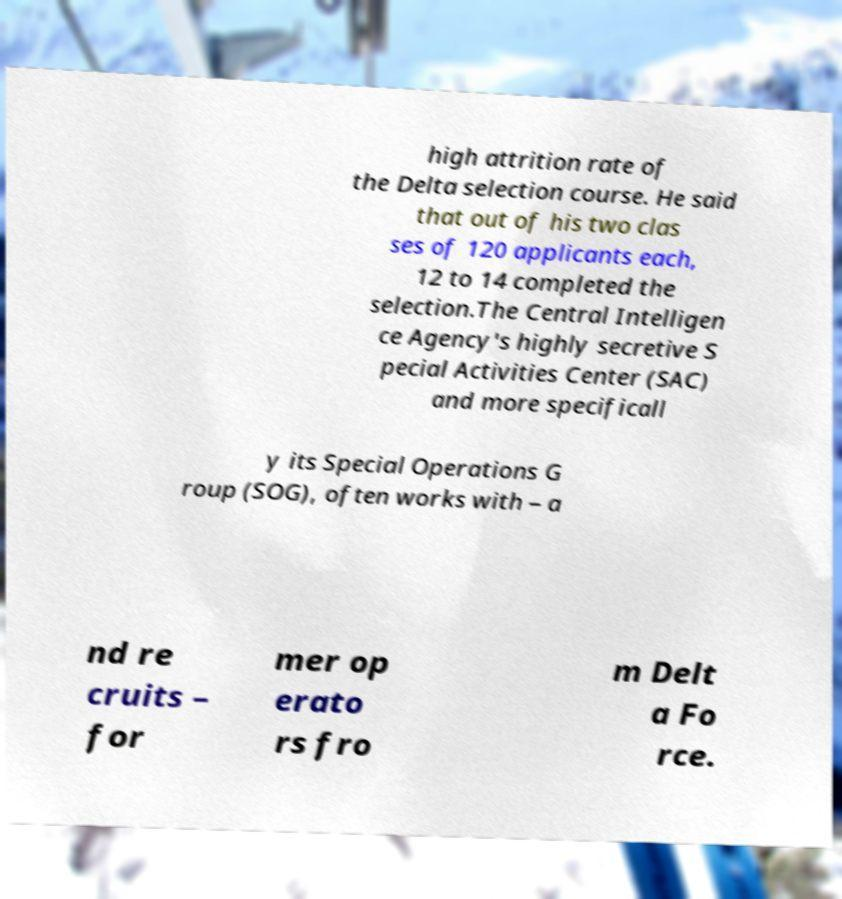For documentation purposes, I need the text within this image transcribed. Could you provide that? high attrition rate of the Delta selection course. He said that out of his two clas ses of 120 applicants each, 12 to 14 completed the selection.The Central Intelligen ce Agency's highly secretive S pecial Activities Center (SAC) and more specificall y its Special Operations G roup (SOG), often works with – a nd re cruits – for mer op erato rs fro m Delt a Fo rce. 